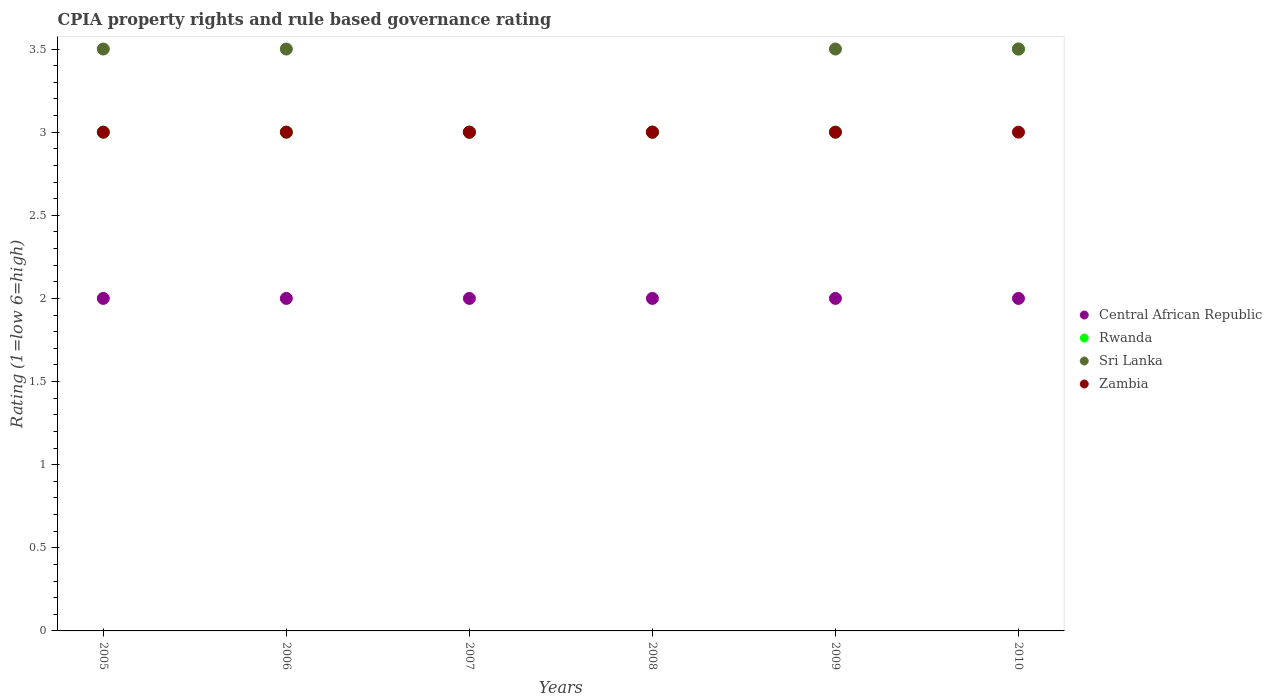How many different coloured dotlines are there?
Offer a terse response. 4. Is the number of dotlines equal to the number of legend labels?
Offer a very short reply. Yes. What is the CPIA rating in Zambia in 2008?
Your response must be concise. 3. Across all years, what is the maximum CPIA rating in Central African Republic?
Provide a succinct answer. 2. Across all years, what is the minimum CPIA rating in Central African Republic?
Provide a succinct answer. 2. In which year was the CPIA rating in Sri Lanka minimum?
Offer a terse response. 2007. What is the total CPIA rating in Sri Lanka in the graph?
Ensure brevity in your answer.  20. What is the difference between the CPIA rating in Central African Republic in 2006 and that in 2009?
Offer a terse response. 0. What is the difference between the CPIA rating in Central African Republic in 2006 and the CPIA rating in Rwanda in 2008?
Your answer should be very brief. -1. What is the average CPIA rating in Rwanda per year?
Your answer should be very brief. 3.08. In how many years, is the CPIA rating in Zambia greater than 1.4?
Make the answer very short. 6. Is the difference between the CPIA rating in Rwanda in 2007 and 2010 greater than the difference between the CPIA rating in Central African Republic in 2007 and 2010?
Give a very brief answer. No. What is the difference between the highest and the lowest CPIA rating in Central African Republic?
Your answer should be very brief. 0. Is the sum of the CPIA rating in Sri Lanka in 2006 and 2010 greater than the maximum CPIA rating in Rwanda across all years?
Provide a short and direct response. Yes. Is it the case that in every year, the sum of the CPIA rating in Rwanda and CPIA rating in Zambia  is greater than the CPIA rating in Sri Lanka?
Keep it short and to the point. Yes. Is the CPIA rating in Sri Lanka strictly greater than the CPIA rating in Central African Republic over the years?
Provide a succinct answer. Yes. Are the values on the major ticks of Y-axis written in scientific E-notation?
Your response must be concise. No. Where does the legend appear in the graph?
Give a very brief answer. Center right. How are the legend labels stacked?
Your answer should be compact. Vertical. What is the title of the graph?
Provide a short and direct response. CPIA property rights and rule based governance rating. What is the label or title of the X-axis?
Your response must be concise. Years. What is the Rating (1=low 6=high) of Central African Republic in 2005?
Make the answer very short. 2. What is the Rating (1=low 6=high) in Sri Lanka in 2005?
Keep it short and to the point. 3.5. What is the Rating (1=low 6=high) in Zambia in 2005?
Ensure brevity in your answer.  3. What is the Rating (1=low 6=high) in Central African Republic in 2007?
Give a very brief answer. 2. What is the Rating (1=low 6=high) in Rwanda in 2007?
Offer a terse response. 3. What is the Rating (1=low 6=high) of Zambia in 2007?
Offer a terse response. 3. What is the Rating (1=low 6=high) in Sri Lanka in 2008?
Ensure brevity in your answer.  3. What is the Rating (1=low 6=high) in Zambia in 2008?
Give a very brief answer. 3. What is the Rating (1=low 6=high) of Sri Lanka in 2009?
Give a very brief answer. 3.5. What is the Rating (1=low 6=high) in Rwanda in 2010?
Provide a short and direct response. 3.5. What is the Rating (1=low 6=high) in Sri Lanka in 2010?
Give a very brief answer. 3.5. What is the Rating (1=low 6=high) of Zambia in 2010?
Keep it short and to the point. 3. Across all years, what is the maximum Rating (1=low 6=high) of Rwanda?
Provide a succinct answer. 3.5. Across all years, what is the maximum Rating (1=low 6=high) in Sri Lanka?
Offer a very short reply. 3.5. Across all years, what is the minimum Rating (1=low 6=high) in Rwanda?
Your response must be concise. 3. Across all years, what is the minimum Rating (1=low 6=high) in Sri Lanka?
Provide a succinct answer. 3. Across all years, what is the minimum Rating (1=low 6=high) in Zambia?
Your response must be concise. 3. What is the total Rating (1=low 6=high) in Central African Republic in the graph?
Provide a succinct answer. 12. What is the total Rating (1=low 6=high) in Rwanda in the graph?
Keep it short and to the point. 18.5. What is the total Rating (1=low 6=high) in Zambia in the graph?
Your answer should be very brief. 18. What is the difference between the Rating (1=low 6=high) in Central African Republic in 2005 and that in 2006?
Provide a short and direct response. 0. What is the difference between the Rating (1=low 6=high) in Rwanda in 2005 and that in 2006?
Your response must be concise. 0. What is the difference between the Rating (1=low 6=high) of Central African Republic in 2005 and that in 2007?
Ensure brevity in your answer.  0. What is the difference between the Rating (1=low 6=high) in Rwanda in 2005 and that in 2007?
Keep it short and to the point. 0. What is the difference between the Rating (1=low 6=high) in Sri Lanka in 2005 and that in 2007?
Keep it short and to the point. 0.5. What is the difference between the Rating (1=low 6=high) in Zambia in 2005 and that in 2007?
Offer a very short reply. 0. What is the difference between the Rating (1=low 6=high) in Central African Republic in 2005 and that in 2008?
Ensure brevity in your answer.  0. What is the difference between the Rating (1=low 6=high) in Central African Republic in 2005 and that in 2009?
Make the answer very short. 0. What is the difference between the Rating (1=low 6=high) in Sri Lanka in 2005 and that in 2009?
Your answer should be compact. 0. What is the difference between the Rating (1=low 6=high) in Zambia in 2005 and that in 2009?
Provide a succinct answer. 0. What is the difference between the Rating (1=low 6=high) of Central African Republic in 2005 and that in 2010?
Provide a short and direct response. 0. What is the difference between the Rating (1=low 6=high) in Sri Lanka in 2005 and that in 2010?
Give a very brief answer. 0. What is the difference between the Rating (1=low 6=high) in Zambia in 2005 and that in 2010?
Make the answer very short. 0. What is the difference between the Rating (1=low 6=high) of Rwanda in 2006 and that in 2007?
Keep it short and to the point. 0. What is the difference between the Rating (1=low 6=high) of Sri Lanka in 2006 and that in 2007?
Make the answer very short. 0.5. What is the difference between the Rating (1=low 6=high) in Zambia in 2006 and that in 2007?
Your answer should be very brief. 0. What is the difference between the Rating (1=low 6=high) in Central African Republic in 2006 and that in 2008?
Provide a short and direct response. 0. What is the difference between the Rating (1=low 6=high) of Rwanda in 2006 and that in 2008?
Ensure brevity in your answer.  0. What is the difference between the Rating (1=low 6=high) of Zambia in 2006 and that in 2008?
Offer a terse response. 0. What is the difference between the Rating (1=low 6=high) in Sri Lanka in 2006 and that in 2009?
Offer a very short reply. 0. What is the difference between the Rating (1=low 6=high) of Zambia in 2006 and that in 2009?
Your answer should be compact. 0. What is the difference between the Rating (1=low 6=high) in Rwanda in 2006 and that in 2010?
Offer a very short reply. -0.5. What is the difference between the Rating (1=low 6=high) of Sri Lanka in 2006 and that in 2010?
Ensure brevity in your answer.  0. What is the difference between the Rating (1=low 6=high) in Zambia in 2006 and that in 2010?
Offer a very short reply. 0. What is the difference between the Rating (1=low 6=high) of Sri Lanka in 2007 and that in 2008?
Your response must be concise. 0. What is the difference between the Rating (1=low 6=high) in Rwanda in 2007 and that in 2009?
Provide a succinct answer. 0. What is the difference between the Rating (1=low 6=high) of Zambia in 2007 and that in 2009?
Your response must be concise. 0. What is the difference between the Rating (1=low 6=high) in Central African Republic in 2007 and that in 2010?
Offer a terse response. 0. What is the difference between the Rating (1=low 6=high) in Rwanda in 2007 and that in 2010?
Your response must be concise. -0.5. What is the difference between the Rating (1=low 6=high) of Sri Lanka in 2007 and that in 2010?
Your answer should be compact. -0.5. What is the difference between the Rating (1=low 6=high) of Zambia in 2007 and that in 2010?
Provide a short and direct response. 0. What is the difference between the Rating (1=low 6=high) of Central African Republic in 2008 and that in 2009?
Make the answer very short. 0. What is the difference between the Rating (1=low 6=high) of Rwanda in 2008 and that in 2009?
Ensure brevity in your answer.  0. What is the difference between the Rating (1=low 6=high) in Zambia in 2008 and that in 2010?
Your answer should be very brief. 0. What is the difference between the Rating (1=low 6=high) in Central African Republic in 2009 and that in 2010?
Provide a succinct answer. 0. What is the difference between the Rating (1=low 6=high) in Sri Lanka in 2009 and that in 2010?
Your response must be concise. 0. What is the difference between the Rating (1=low 6=high) of Central African Republic in 2005 and the Rating (1=low 6=high) of Rwanda in 2006?
Your answer should be compact. -1. What is the difference between the Rating (1=low 6=high) of Central African Republic in 2005 and the Rating (1=low 6=high) of Sri Lanka in 2006?
Ensure brevity in your answer.  -1.5. What is the difference between the Rating (1=low 6=high) of Rwanda in 2005 and the Rating (1=low 6=high) of Sri Lanka in 2006?
Your response must be concise. -0.5. What is the difference between the Rating (1=low 6=high) of Sri Lanka in 2005 and the Rating (1=low 6=high) of Zambia in 2006?
Give a very brief answer. 0.5. What is the difference between the Rating (1=low 6=high) of Central African Republic in 2005 and the Rating (1=low 6=high) of Rwanda in 2007?
Offer a terse response. -1. What is the difference between the Rating (1=low 6=high) in Central African Republic in 2005 and the Rating (1=low 6=high) in Zambia in 2007?
Make the answer very short. -1. What is the difference between the Rating (1=low 6=high) of Rwanda in 2005 and the Rating (1=low 6=high) of Zambia in 2007?
Offer a terse response. 0. What is the difference between the Rating (1=low 6=high) in Central African Republic in 2005 and the Rating (1=low 6=high) in Rwanda in 2008?
Ensure brevity in your answer.  -1. What is the difference between the Rating (1=low 6=high) of Sri Lanka in 2005 and the Rating (1=low 6=high) of Zambia in 2008?
Give a very brief answer. 0.5. What is the difference between the Rating (1=low 6=high) in Rwanda in 2005 and the Rating (1=low 6=high) in Sri Lanka in 2009?
Provide a succinct answer. -0.5. What is the difference between the Rating (1=low 6=high) of Rwanda in 2005 and the Rating (1=low 6=high) of Zambia in 2009?
Your answer should be very brief. 0. What is the difference between the Rating (1=low 6=high) of Central African Republic in 2005 and the Rating (1=low 6=high) of Rwanda in 2010?
Provide a short and direct response. -1.5. What is the difference between the Rating (1=low 6=high) in Central African Republic in 2005 and the Rating (1=low 6=high) in Sri Lanka in 2010?
Give a very brief answer. -1.5. What is the difference between the Rating (1=low 6=high) in Central African Republic in 2005 and the Rating (1=low 6=high) in Zambia in 2010?
Your answer should be very brief. -1. What is the difference between the Rating (1=low 6=high) in Rwanda in 2005 and the Rating (1=low 6=high) in Zambia in 2010?
Keep it short and to the point. 0. What is the difference between the Rating (1=low 6=high) in Central African Republic in 2006 and the Rating (1=low 6=high) in Sri Lanka in 2007?
Keep it short and to the point. -1. What is the difference between the Rating (1=low 6=high) in Rwanda in 2006 and the Rating (1=low 6=high) in Sri Lanka in 2007?
Your answer should be compact. 0. What is the difference between the Rating (1=low 6=high) in Rwanda in 2006 and the Rating (1=low 6=high) in Zambia in 2007?
Your response must be concise. 0. What is the difference between the Rating (1=low 6=high) of Central African Republic in 2006 and the Rating (1=low 6=high) of Sri Lanka in 2008?
Make the answer very short. -1. What is the difference between the Rating (1=low 6=high) in Central African Republic in 2006 and the Rating (1=low 6=high) in Zambia in 2008?
Provide a short and direct response. -1. What is the difference between the Rating (1=low 6=high) of Rwanda in 2006 and the Rating (1=low 6=high) of Zambia in 2008?
Your answer should be compact. 0. What is the difference between the Rating (1=low 6=high) in Central African Republic in 2006 and the Rating (1=low 6=high) in Sri Lanka in 2009?
Offer a very short reply. -1.5. What is the difference between the Rating (1=low 6=high) of Central African Republic in 2006 and the Rating (1=low 6=high) of Zambia in 2009?
Offer a very short reply. -1. What is the difference between the Rating (1=low 6=high) in Rwanda in 2006 and the Rating (1=low 6=high) in Sri Lanka in 2009?
Provide a short and direct response. -0.5. What is the difference between the Rating (1=low 6=high) of Central African Republic in 2006 and the Rating (1=low 6=high) of Rwanda in 2010?
Provide a succinct answer. -1.5. What is the difference between the Rating (1=low 6=high) of Central African Republic in 2006 and the Rating (1=low 6=high) of Sri Lanka in 2010?
Keep it short and to the point. -1.5. What is the difference between the Rating (1=low 6=high) of Sri Lanka in 2006 and the Rating (1=low 6=high) of Zambia in 2010?
Give a very brief answer. 0.5. What is the difference between the Rating (1=low 6=high) in Central African Republic in 2007 and the Rating (1=low 6=high) in Rwanda in 2008?
Ensure brevity in your answer.  -1. What is the difference between the Rating (1=low 6=high) in Central African Republic in 2007 and the Rating (1=low 6=high) in Zambia in 2008?
Keep it short and to the point. -1. What is the difference between the Rating (1=low 6=high) of Rwanda in 2007 and the Rating (1=low 6=high) of Sri Lanka in 2008?
Make the answer very short. 0. What is the difference between the Rating (1=low 6=high) of Rwanda in 2007 and the Rating (1=low 6=high) of Zambia in 2008?
Offer a terse response. 0. What is the difference between the Rating (1=low 6=high) of Central African Republic in 2007 and the Rating (1=low 6=high) of Zambia in 2009?
Your answer should be very brief. -1. What is the difference between the Rating (1=low 6=high) in Rwanda in 2007 and the Rating (1=low 6=high) in Sri Lanka in 2009?
Offer a terse response. -0.5. What is the difference between the Rating (1=low 6=high) of Rwanda in 2007 and the Rating (1=low 6=high) of Zambia in 2009?
Offer a very short reply. 0. What is the difference between the Rating (1=low 6=high) of Sri Lanka in 2007 and the Rating (1=low 6=high) of Zambia in 2009?
Offer a very short reply. 0. What is the difference between the Rating (1=low 6=high) in Central African Republic in 2007 and the Rating (1=low 6=high) in Rwanda in 2010?
Ensure brevity in your answer.  -1.5. What is the difference between the Rating (1=low 6=high) of Central African Republic in 2007 and the Rating (1=low 6=high) of Sri Lanka in 2010?
Your answer should be very brief. -1.5. What is the difference between the Rating (1=low 6=high) of Sri Lanka in 2007 and the Rating (1=low 6=high) of Zambia in 2010?
Your answer should be very brief. 0. What is the difference between the Rating (1=low 6=high) in Central African Republic in 2008 and the Rating (1=low 6=high) in Rwanda in 2009?
Your answer should be compact. -1. What is the difference between the Rating (1=low 6=high) of Sri Lanka in 2008 and the Rating (1=low 6=high) of Zambia in 2009?
Your answer should be very brief. 0. What is the difference between the Rating (1=low 6=high) in Rwanda in 2008 and the Rating (1=low 6=high) in Zambia in 2010?
Make the answer very short. 0. What is the difference between the Rating (1=low 6=high) of Central African Republic in 2009 and the Rating (1=low 6=high) of Rwanda in 2010?
Offer a terse response. -1.5. What is the difference between the Rating (1=low 6=high) in Central African Republic in 2009 and the Rating (1=low 6=high) in Sri Lanka in 2010?
Ensure brevity in your answer.  -1.5. What is the difference between the Rating (1=low 6=high) of Central African Republic in 2009 and the Rating (1=low 6=high) of Zambia in 2010?
Provide a succinct answer. -1. What is the difference between the Rating (1=low 6=high) in Rwanda in 2009 and the Rating (1=low 6=high) in Zambia in 2010?
Offer a very short reply. 0. What is the average Rating (1=low 6=high) in Central African Republic per year?
Your answer should be very brief. 2. What is the average Rating (1=low 6=high) of Rwanda per year?
Your response must be concise. 3.08. What is the average Rating (1=low 6=high) of Sri Lanka per year?
Provide a short and direct response. 3.33. What is the average Rating (1=low 6=high) in Zambia per year?
Your answer should be compact. 3. In the year 2005, what is the difference between the Rating (1=low 6=high) of Central African Republic and Rating (1=low 6=high) of Sri Lanka?
Ensure brevity in your answer.  -1.5. In the year 2005, what is the difference between the Rating (1=low 6=high) of Rwanda and Rating (1=low 6=high) of Sri Lanka?
Offer a terse response. -0.5. In the year 2005, what is the difference between the Rating (1=low 6=high) of Rwanda and Rating (1=low 6=high) of Zambia?
Ensure brevity in your answer.  0. In the year 2005, what is the difference between the Rating (1=low 6=high) in Sri Lanka and Rating (1=low 6=high) in Zambia?
Your answer should be very brief. 0.5. In the year 2006, what is the difference between the Rating (1=low 6=high) of Central African Republic and Rating (1=low 6=high) of Sri Lanka?
Provide a succinct answer. -1.5. In the year 2006, what is the difference between the Rating (1=low 6=high) of Rwanda and Rating (1=low 6=high) of Sri Lanka?
Offer a terse response. -0.5. In the year 2006, what is the difference between the Rating (1=low 6=high) in Sri Lanka and Rating (1=low 6=high) in Zambia?
Offer a very short reply. 0.5. In the year 2007, what is the difference between the Rating (1=low 6=high) in Central African Republic and Rating (1=low 6=high) in Rwanda?
Make the answer very short. -1. In the year 2007, what is the difference between the Rating (1=low 6=high) in Central African Republic and Rating (1=low 6=high) in Zambia?
Your response must be concise. -1. In the year 2007, what is the difference between the Rating (1=low 6=high) of Rwanda and Rating (1=low 6=high) of Sri Lanka?
Offer a very short reply. 0. In the year 2007, what is the difference between the Rating (1=low 6=high) of Sri Lanka and Rating (1=low 6=high) of Zambia?
Offer a very short reply. 0. In the year 2008, what is the difference between the Rating (1=low 6=high) in Central African Republic and Rating (1=low 6=high) in Rwanda?
Offer a terse response. -1. In the year 2008, what is the difference between the Rating (1=low 6=high) of Central African Republic and Rating (1=low 6=high) of Zambia?
Keep it short and to the point. -1. In the year 2008, what is the difference between the Rating (1=low 6=high) in Rwanda and Rating (1=low 6=high) in Sri Lanka?
Offer a very short reply. 0. In the year 2009, what is the difference between the Rating (1=low 6=high) in Central African Republic and Rating (1=low 6=high) in Zambia?
Ensure brevity in your answer.  -1. In the year 2009, what is the difference between the Rating (1=low 6=high) in Rwanda and Rating (1=low 6=high) in Sri Lanka?
Your response must be concise. -0.5. In the year 2009, what is the difference between the Rating (1=low 6=high) of Rwanda and Rating (1=low 6=high) of Zambia?
Offer a very short reply. 0. In the year 2010, what is the difference between the Rating (1=low 6=high) in Central African Republic and Rating (1=low 6=high) in Rwanda?
Keep it short and to the point. -1.5. In the year 2010, what is the difference between the Rating (1=low 6=high) of Central African Republic and Rating (1=low 6=high) of Sri Lanka?
Give a very brief answer. -1.5. In the year 2010, what is the difference between the Rating (1=low 6=high) of Rwanda and Rating (1=low 6=high) of Zambia?
Offer a terse response. 0.5. What is the ratio of the Rating (1=low 6=high) of Rwanda in 2005 to that in 2006?
Offer a very short reply. 1. What is the ratio of the Rating (1=low 6=high) of Zambia in 2005 to that in 2006?
Offer a terse response. 1. What is the ratio of the Rating (1=low 6=high) in Sri Lanka in 2005 to that in 2007?
Give a very brief answer. 1.17. What is the ratio of the Rating (1=low 6=high) of Zambia in 2005 to that in 2007?
Offer a terse response. 1. What is the ratio of the Rating (1=low 6=high) in Central African Republic in 2005 to that in 2008?
Provide a short and direct response. 1. What is the ratio of the Rating (1=low 6=high) in Rwanda in 2005 to that in 2008?
Give a very brief answer. 1. What is the ratio of the Rating (1=low 6=high) in Sri Lanka in 2005 to that in 2008?
Keep it short and to the point. 1.17. What is the ratio of the Rating (1=low 6=high) of Central African Republic in 2005 to that in 2009?
Provide a succinct answer. 1. What is the ratio of the Rating (1=low 6=high) of Sri Lanka in 2005 to that in 2009?
Your response must be concise. 1. What is the ratio of the Rating (1=low 6=high) of Zambia in 2005 to that in 2009?
Make the answer very short. 1. What is the ratio of the Rating (1=low 6=high) of Central African Republic in 2005 to that in 2010?
Make the answer very short. 1. What is the ratio of the Rating (1=low 6=high) of Sri Lanka in 2005 to that in 2010?
Give a very brief answer. 1. What is the ratio of the Rating (1=low 6=high) in Rwanda in 2006 to that in 2007?
Make the answer very short. 1. What is the ratio of the Rating (1=low 6=high) in Zambia in 2006 to that in 2007?
Your answer should be very brief. 1. What is the ratio of the Rating (1=low 6=high) of Central African Republic in 2006 to that in 2008?
Keep it short and to the point. 1. What is the ratio of the Rating (1=low 6=high) of Rwanda in 2006 to that in 2008?
Your answer should be compact. 1. What is the ratio of the Rating (1=low 6=high) of Sri Lanka in 2006 to that in 2008?
Your response must be concise. 1.17. What is the ratio of the Rating (1=low 6=high) of Central African Republic in 2006 to that in 2009?
Make the answer very short. 1. What is the ratio of the Rating (1=low 6=high) of Sri Lanka in 2006 to that in 2009?
Your answer should be very brief. 1. What is the ratio of the Rating (1=low 6=high) of Rwanda in 2006 to that in 2010?
Give a very brief answer. 0.86. What is the ratio of the Rating (1=low 6=high) in Sri Lanka in 2006 to that in 2010?
Provide a short and direct response. 1. What is the ratio of the Rating (1=low 6=high) of Central African Republic in 2007 to that in 2008?
Provide a short and direct response. 1. What is the ratio of the Rating (1=low 6=high) in Rwanda in 2007 to that in 2008?
Offer a terse response. 1. What is the ratio of the Rating (1=low 6=high) in Sri Lanka in 2007 to that in 2008?
Offer a terse response. 1. What is the ratio of the Rating (1=low 6=high) of Zambia in 2007 to that in 2008?
Give a very brief answer. 1. What is the ratio of the Rating (1=low 6=high) of Rwanda in 2007 to that in 2009?
Your answer should be very brief. 1. What is the ratio of the Rating (1=low 6=high) in Zambia in 2007 to that in 2009?
Provide a short and direct response. 1. What is the ratio of the Rating (1=low 6=high) in Rwanda in 2007 to that in 2010?
Give a very brief answer. 0.86. What is the ratio of the Rating (1=low 6=high) in Zambia in 2007 to that in 2010?
Offer a very short reply. 1. What is the ratio of the Rating (1=low 6=high) of Central African Republic in 2008 to that in 2009?
Provide a short and direct response. 1. What is the ratio of the Rating (1=low 6=high) in Rwanda in 2008 to that in 2009?
Make the answer very short. 1. What is the ratio of the Rating (1=low 6=high) in Central African Republic in 2008 to that in 2010?
Your answer should be compact. 1. What is the ratio of the Rating (1=low 6=high) of Sri Lanka in 2008 to that in 2010?
Your response must be concise. 0.86. What is the ratio of the Rating (1=low 6=high) of Zambia in 2008 to that in 2010?
Your response must be concise. 1. What is the ratio of the Rating (1=low 6=high) of Central African Republic in 2009 to that in 2010?
Your answer should be very brief. 1. What is the ratio of the Rating (1=low 6=high) in Rwanda in 2009 to that in 2010?
Provide a short and direct response. 0.86. What is the ratio of the Rating (1=low 6=high) of Zambia in 2009 to that in 2010?
Provide a succinct answer. 1. What is the difference between the highest and the second highest Rating (1=low 6=high) in Sri Lanka?
Offer a terse response. 0. What is the difference between the highest and the second highest Rating (1=low 6=high) of Zambia?
Offer a very short reply. 0. What is the difference between the highest and the lowest Rating (1=low 6=high) in Central African Republic?
Give a very brief answer. 0. What is the difference between the highest and the lowest Rating (1=low 6=high) in Rwanda?
Provide a succinct answer. 0.5. What is the difference between the highest and the lowest Rating (1=low 6=high) in Zambia?
Give a very brief answer. 0. 